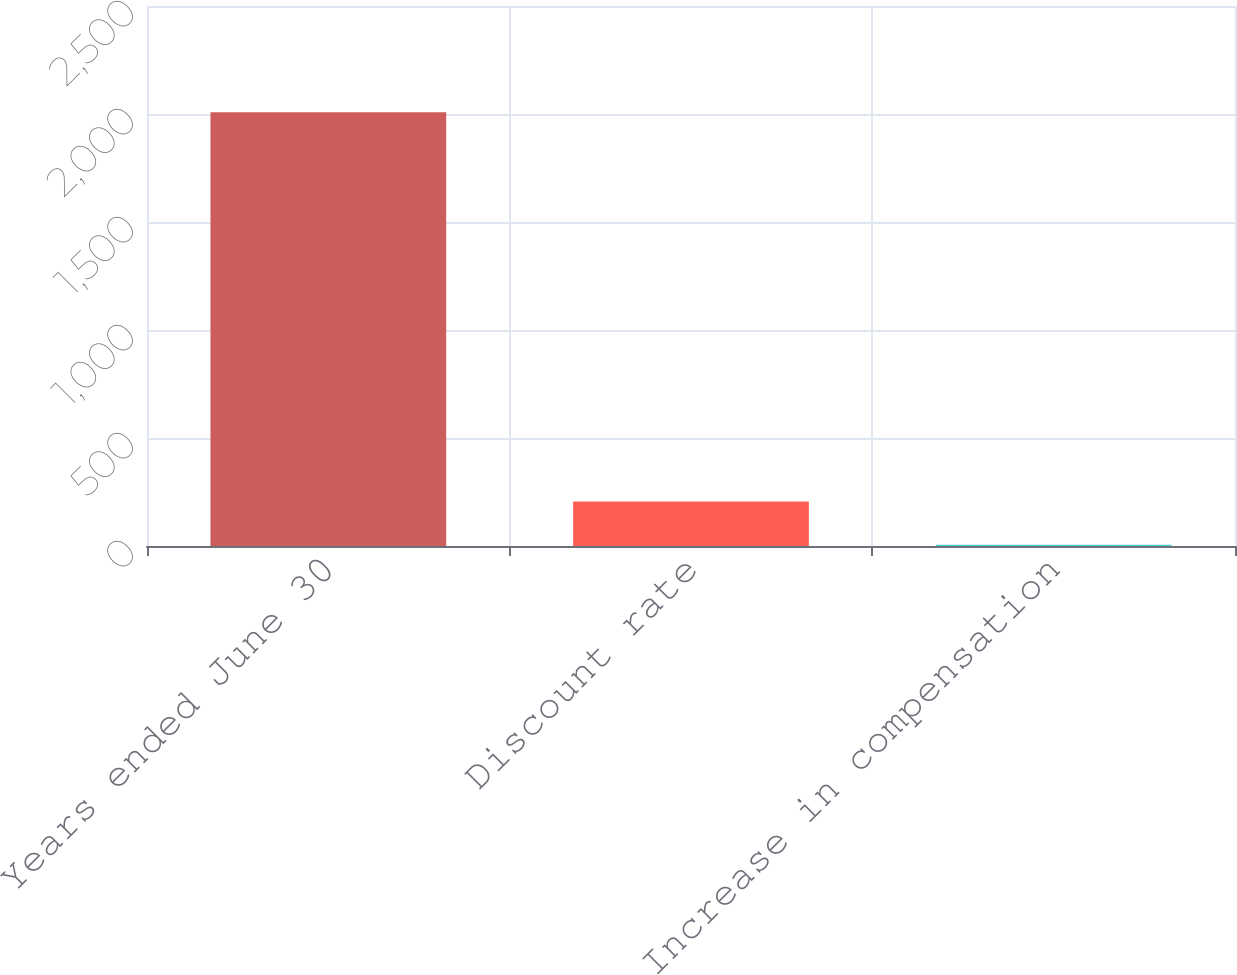Convert chart. <chart><loc_0><loc_0><loc_500><loc_500><bar_chart><fcel>Years ended June 30<fcel>Discount rate<fcel>Increase in compensation<nl><fcel>2008<fcel>205.75<fcel>5.5<nl></chart> 